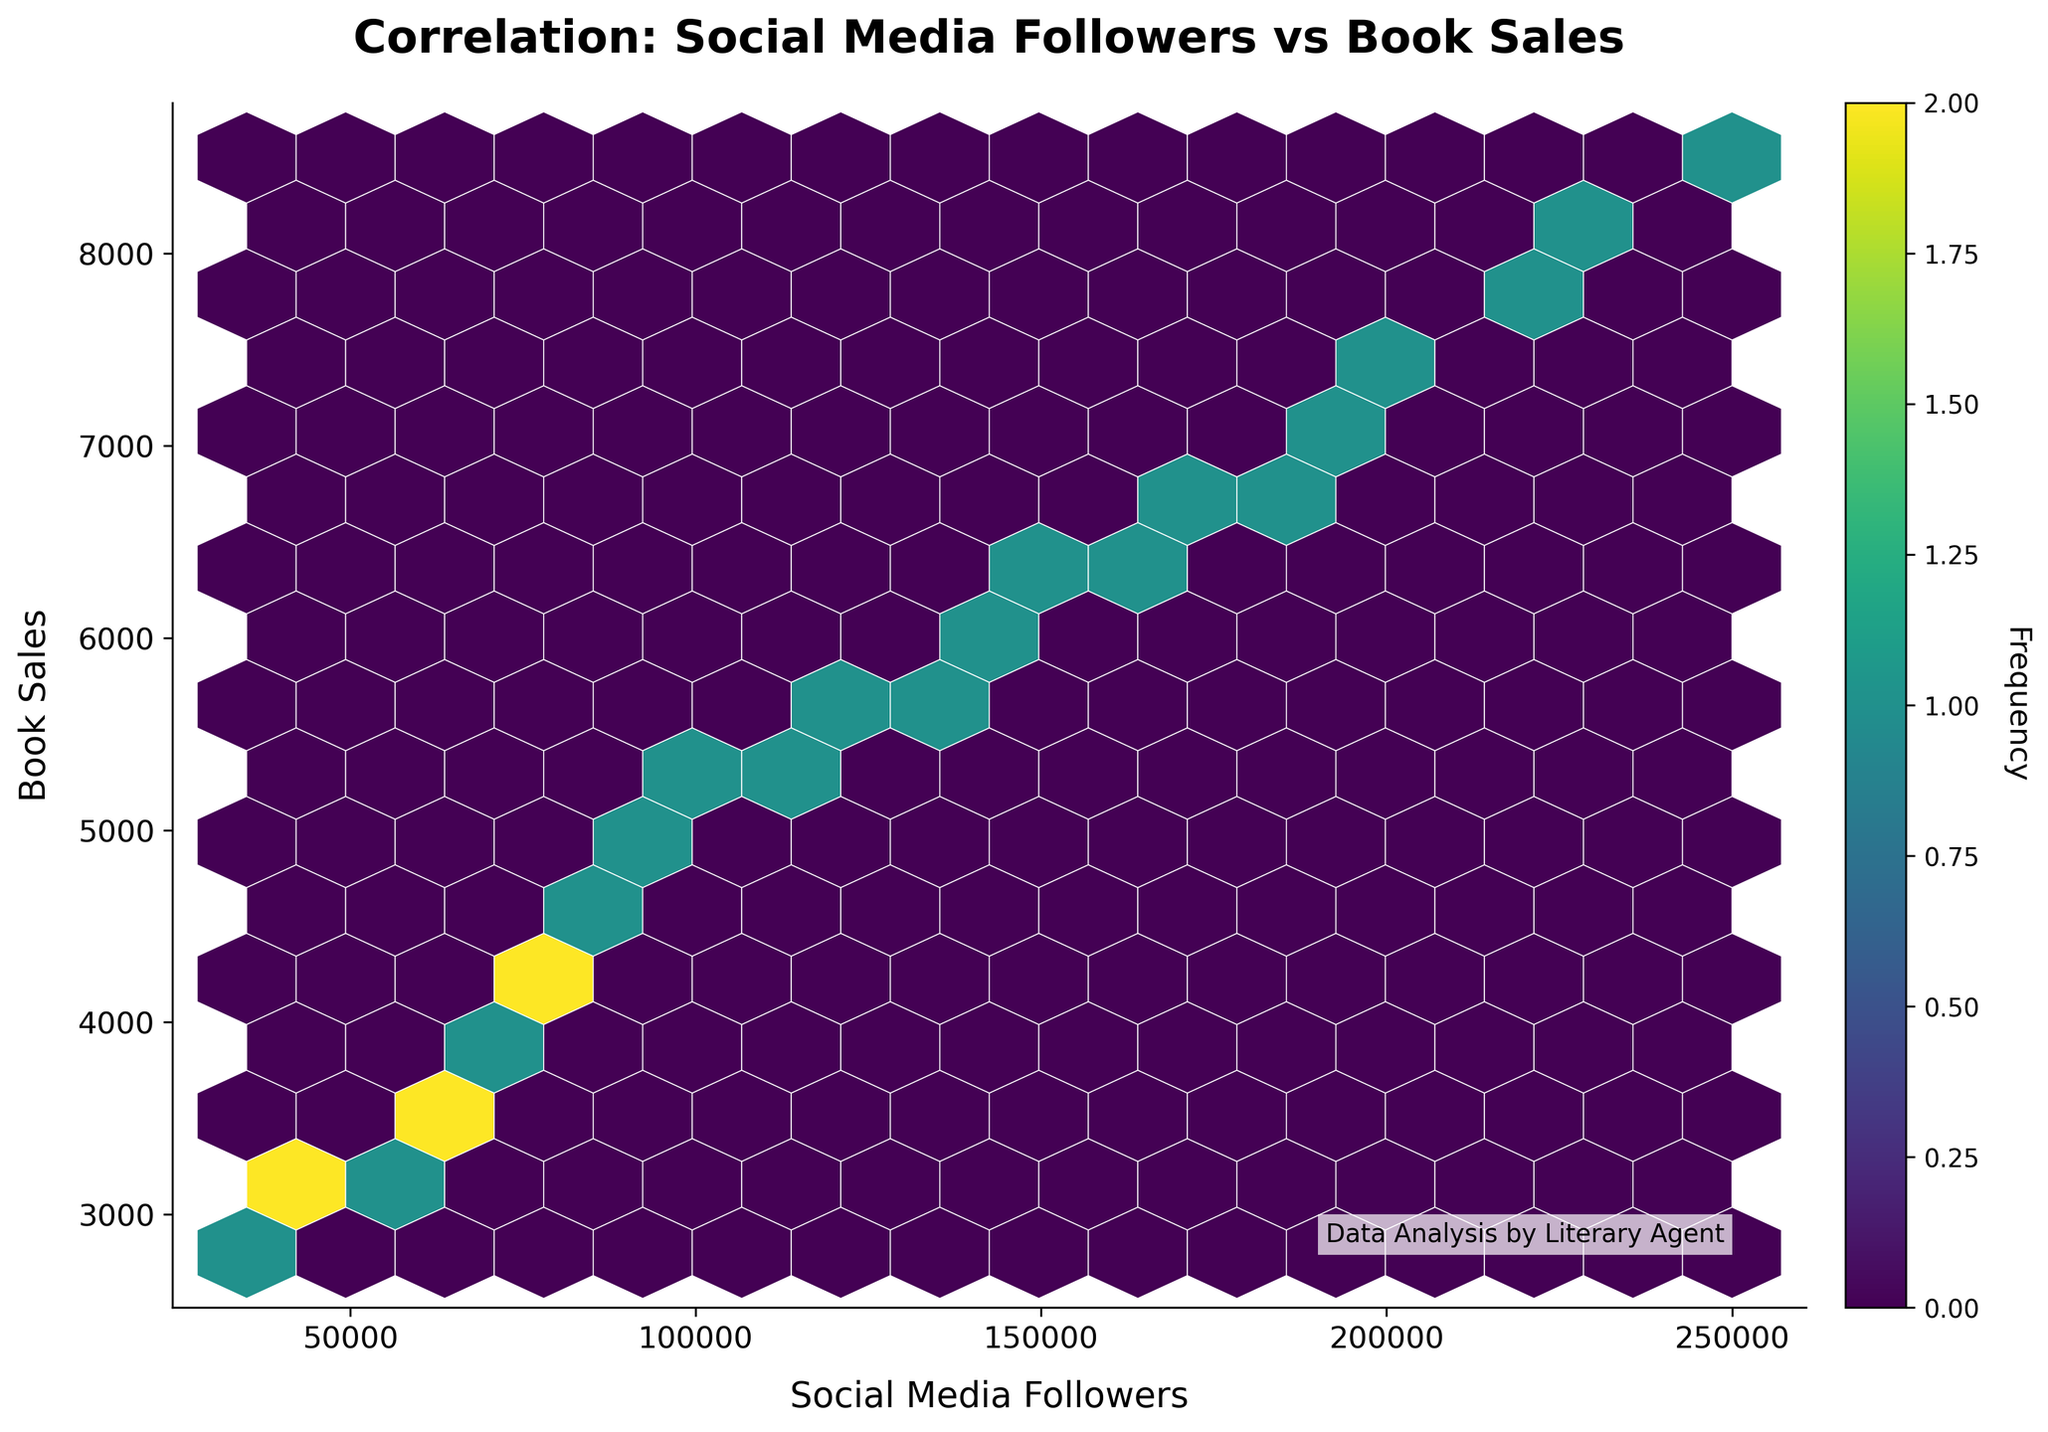What is the title of the plot? The title is clearly labeled at the top of the figure and it reads "Correlation: Social Media Followers vs Book Sales".
Answer: Correlation: Social Media Followers vs Book Sales Can you identify the x-axis and y-axis labels in the figure? The x-axis label is "Social Media Followers" and the y-axis label is "Book Sales", as denoted at the bottom and the left side of the plot, respectively.
Answer: Social Media Followers and Book Sales Which color is used to represent higher frequency in the plot? The plot utilizes the viridis color map, which means higher frequency bins are represented with lighter colors, transitioning from dark purple to yellow.
Answer: Yellow How many hexagons are used to represent the data points on the plot? By analyzing the hexagonal grid, one can identify specific bins; the figure indicates 15 hexagons across the grid.
Answer: 15 What does a dense yellow area indicate in this plot? A dense yellow area signals a high frequency of data points in that hexagonal bin, showing a strong concentration of social media follower count and book sales within that range.
Answer: High frequency of data points Where is the color bar located, and what is its label? The color bar is found on the right side of the plot and is labeled "Frequency" rotated 270 degrees.
Answer: Right side, Frequency Looking at the hexbin plot, which combination of social media followers and book sales is most populous? The bins with the lightest color, indicating the highest frequency, are around 100,000 to 150,000 social media followers and 5,200 to 6,200 book sales.
Answer: 100,000 to 150,000 followers; 5,200 to 6,200 sales Are there any hexagons with a frequency of fewer than 3 data points? The color bar indicates the frequency scale, and the hexagons that are dark purple correspond to the lower end of the frequency scale, showing fewer than 3 data points.
Answer: Yes, dark purple hexagons How does the frequency of social media followers correlate with book sales? By examining the spread and concentration of hexagons, a positive correlation can be inferred: higher social media followers tend to align with higher book sales.
Answer: Positive correlation 